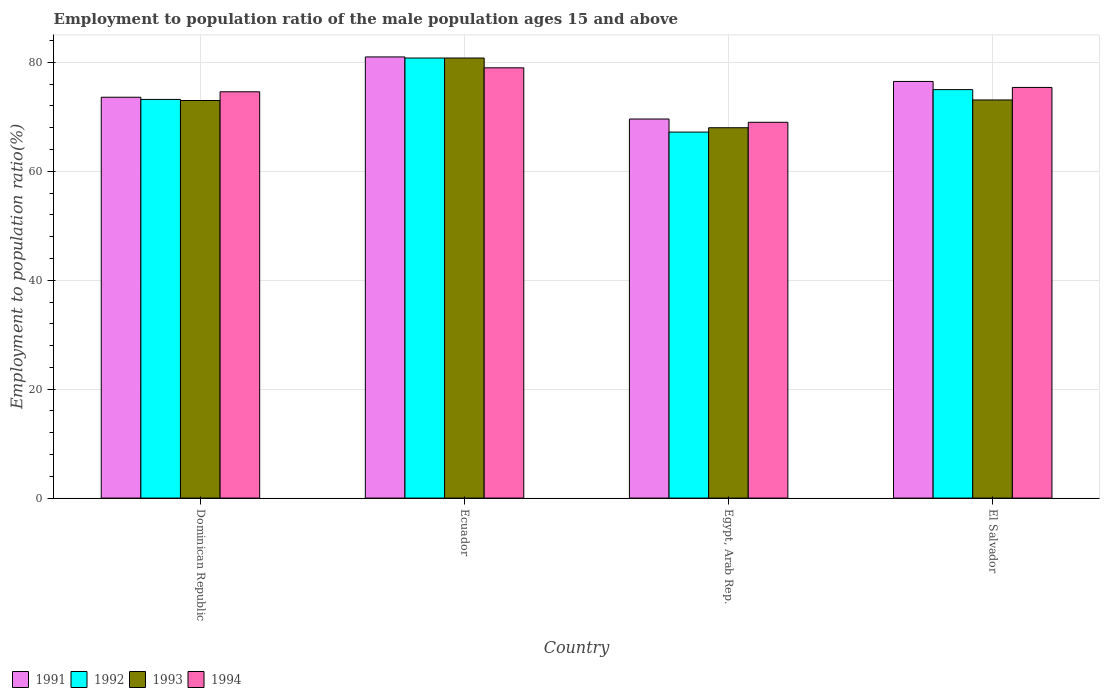What is the label of the 2nd group of bars from the left?
Give a very brief answer. Ecuador. What is the employment to population ratio in 1993 in El Salvador?
Provide a succinct answer. 73.1. Across all countries, what is the maximum employment to population ratio in 1994?
Your answer should be compact. 79. Across all countries, what is the minimum employment to population ratio in 1991?
Ensure brevity in your answer.  69.6. In which country was the employment to population ratio in 1994 maximum?
Ensure brevity in your answer.  Ecuador. In which country was the employment to population ratio in 1993 minimum?
Your answer should be compact. Egypt, Arab Rep. What is the total employment to population ratio in 1994 in the graph?
Provide a succinct answer. 298. What is the difference between the employment to population ratio in 1993 in El Salvador and the employment to population ratio in 1991 in Ecuador?
Provide a short and direct response. -7.9. What is the average employment to population ratio in 1993 per country?
Your response must be concise. 73.73. What is the difference between the employment to population ratio of/in 1994 and employment to population ratio of/in 1991 in Egypt, Arab Rep.?
Make the answer very short. -0.6. In how many countries, is the employment to population ratio in 1994 greater than 12 %?
Ensure brevity in your answer.  4. What is the ratio of the employment to population ratio in 1993 in Dominican Republic to that in Ecuador?
Offer a terse response. 0.9. Is the employment to population ratio in 1994 in Ecuador less than that in Egypt, Arab Rep.?
Ensure brevity in your answer.  No. What is the difference between the highest and the second highest employment to population ratio in 1991?
Provide a succinct answer. -7.4. What is the difference between the highest and the lowest employment to population ratio in 1994?
Provide a short and direct response. 10. Is it the case that in every country, the sum of the employment to population ratio in 1994 and employment to population ratio in 1991 is greater than the sum of employment to population ratio in 1992 and employment to population ratio in 1993?
Ensure brevity in your answer.  No. What does the 2nd bar from the right in Dominican Republic represents?
Your answer should be compact. 1993. Are all the bars in the graph horizontal?
Provide a short and direct response. No. What is the difference between two consecutive major ticks on the Y-axis?
Offer a very short reply. 20. Does the graph contain any zero values?
Your answer should be very brief. No. Does the graph contain grids?
Your answer should be compact. Yes. How are the legend labels stacked?
Your answer should be compact. Horizontal. What is the title of the graph?
Offer a terse response. Employment to population ratio of the male population ages 15 and above. What is the label or title of the X-axis?
Make the answer very short. Country. What is the label or title of the Y-axis?
Provide a short and direct response. Employment to population ratio(%). What is the Employment to population ratio(%) in 1991 in Dominican Republic?
Keep it short and to the point. 73.6. What is the Employment to population ratio(%) in 1992 in Dominican Republic?
Ensure brevity in your answer.  73.2. What is the Employment to population ratio(%) in 1994 in Dominican Republic?
Your answer should be very brief. 74.6. What is the Employment to population ratio(%) in 1992 in Ecuador?
Your answer should be very brief. 80.8. What is the Employment to population ratio(%) of 1993 in Ecuador?
Your answer should be compact. 80.8. What is the Employment to population ratio(%) of 1994 in Ecuador?
Your answer should be compact. 79. What is the Employment to population ratio(%) of 1991 in Egypt, Arab Rep.?
Offer a terse response. 69.6. What is the Employment to population ratio(%) in 1992 in Egypt, Arab Rep.?
Ensure brevity in your answer.  67.2. What is the Employment to population ratio(%) in 1993 in Egypt, Arab Rep.?
Give a very brief answer. 68. What is the Employment to population ratio(%) in 1991 in El Salvador?
Your answer should be compact. 76.5. What is the Employment to population ratio(%) in 1992 in El Salvador?
Provide a succinct answer. 75. What is the Employment to population ratio(%) in 1993 in El Salvador?
Your answer should be very brief. 73.1. What is the Employment to population ratio(%) in 1994 in El Salvador?
Your answer should be compact. 75.4. Across all countries, what is the maximum Employment to population ratio(%) of 1992?
Offer a very short reply. 80.8. Across all countries, what is the maximum Employment to population ratio(%) of 1993?
Offer a very short reply. 80.8. Across all countries, what is the maximum Employment to population ratio(%) of 1994?
Your answer should be very brief. 79. Across all countries, what is the minimum Employment to population ratio(%) of 1991?
Offer a terse response. 69.6. Across all countries, what is the minimum Employment to population ratio(%) in 1992?
Your answer should be compact. 67.2. What is the total Employment to population ratio(%) of 1991 in the graph?
Provide a succinct answer. 300.7. What is the total Employment to population ratio(%) of 1992 in the graph?
Keep it short and to the point. 296.2. What is the total Employment to population ratio(%) of 1993 in the graph?
Make the answer very short. 294.9. What is the total Employment to population ratio(%) in 1994 in the graph?
Your answer should be very brief. 298. What is the difference between the Employment to population ratio(%) of 1991 in Dominican Republic and that in Ecuador?
Provide a short and direct response. -7.4. What is the difference between the Employment to population ratio(%) of 1993 in Dominican Republic and that in Ecuador?
Ensure brevity in your answer.  -7.8. What is the difference between the Employment to population ratio(%) of 1994 in Dominican Republic and that in Ecuador?
Your response must be concise. -4.4. What is the difference between the Employment to population ratio(%) in 1993 in Dominican Republic and that in Egypt, Arab Rep.?
Your response must be concise. 5. What is the difference between the Employment to population ratio(%) of 1992 in Dominican Republic and that in El Salvador?
Keep it short and to the point. -1.8. What is the difference between the Employment to population ratio(%) in 1993 in Dominican Republic and that in El Salvador?
Your answer should be compact. -0.1. What is the difference between the Employment to population ratio(%) of 1991 in Ecuador and that in Egypt, Arab Rep.?
Offer a terse response. 11.4. What is the difference between the Employment to population ratio(%) of 1994 in Ecuador and that in Egypt, Arab Rep.?
Keep it short and to the point. 10. What is the difference between the Employment to population ratio(%) of 1992 in Ecuador and that in El Salvador?
Offer a terse response. 5.8. What is the difference between the Employment to population ratio(%) of 1993 in Ecuador and that in El Salvador?
Your answer should be compact. 7.7. What is the difference between the Employment to population ratio(%) in 1991 in Egypt, Arab Rep. and that in El Salvador?
Keep it short and to the point. -6.9. What is the difference between the Employment to population ratio(%) in 1991 in Dominican Republic and the Employment to population ratio(%) in 1993 in Ecuador?
Give a very brief answer. -7.2. What is the difference between the Employment to population ratio(%) of 1991 in Dominican Republic and the Employment to population ratio(%) of 1994 in Ecuador?
Offer a very short reply. -5.4. What is the difference between the Employment to population ratio(%) of 1991 in Dominican Republic and the Employment to population ratio(%) of 1993 in Egypt, Arab Rep.?
Give a very brief answer. 5.6. What is the difference between the Employment to population ratio(%) of 1991 in Dominican Republic and the Employment to population ratio(%) of 1994 in Egypt, Arab Rep.?
Provide a succinct answer. 4.6. What is the difference between the Employment to population ratio(%) in 1992 in Dominican Republic and the Employment to population ratio(%) in 1994 in Egypt, Arab Rep.?
Provide a short and direct response. 4.2. What is the difference between the Employment to population ratio(%) in 1991 in Dominican Republic and the Employment to population ratio(%) in 1992 in El Salvador?
Give a very brief answer. -1.4. What is the difference between the Employment to population ratio(%) of 1991 in Dominican Republic and the Employment to population ratio(%) of 1993 in El Salvador?
Your answer should be compact. 0.5. What is the difference between the Employment to population ratio(%) in 1992 in Dominican Republic and the Employment to population ratio(%) in 1994 in El Salvador?
Give a very brief answer. -2.2. What is the difference between the Employment to population ratio(%) in 1991 in Ecuador and the Employment to population ratio(%) in 1994 in Egypt, Arab Rep.?
Offer a very short reply. 12. What is the difference between the Employment to population ratio(%) of 1992 in Ecuador and the Employment to population ratio(%) of 1993 in Egypt, Arab Rep.?
Provide a succinct answer. 12.8. What is the difference between the Employment to population ratio(%) in 1991 in Ecuador and the Employment to population ratio(%) in 1994 in El Salvador?
Offer a terse response. 5.6. What is the difference between the Employment to population ratio(%) in 1992 in Ecuador and the Employment to population ratio(%) in 1993 in El Salvador?
Offer a terse response. 7.7. What is the difference between the Employment to population ratio(%) in 1992 in Egypt, Arab Rep. and the Employment to population ratio(%) in 1993 in El Salvador?
Ensure brevity in your answer.  -5.9. What is the average Employment to population ratio(%) of 1991 per country?
Keep it short and to the point. 75.17. What is the average Employment to population ratio(%) of 1992 per country?
Provide a short and direct response. 74.05. What is the average Employment to population ratio(%) in 1993 per country?
Your response must be concise. 73.72. What is the average Employment to population ratio(%) in 1994 per country?
Your answer should be compact. 74.5. What is the difference between the Employment to population ratio(%) in 1992 and Employment to population ratio(%) in 1994 in Dominican Republic?
Provide a succinct answer. -1.4. What is the difference between the Employment to population ratio(%) of 1993 and Employment to population ratio(%) of 1994 in Dominican Republic?
Your answer should be compact. -1.6. What is the difference between the Employment to population ratio(%) of 1991 and Employment to population ratio(%) of 1993 in Ecuador?
Offer a very short reply. 0.2. What is the difference between the Employment to population ratio(%) in 1991 and Employment to population ratio(%) in 1994 in Ecuador?
Your response must be concise. 2. What is the difference between the Employment to population ratio(%) of 1993 and Employment to population ratio(%) of 1994 in Ecuador?
Your answer should be compact. 1.8. What is the difference between the Employment to population ratio(%) in 1991 and Employment to population ratio(%) in 1994 in Egypt, Arab Rep.?
Give a very brief answer. 0.6. What is the difference between the Employment to population ratio(%) in 1991 and Employment to population ratio(%) in 1992 in El Salvador?
Offer a terse response. 1.5. What is the difference between the Employment to population ratio(%) in 1991 and Employment to population ratio(%) in 1993 in El Salvador?
Keep it short and to the point. 3.4. What is the difference between the Employment to population ratio(%) in 1991 and Employment to population ratio(%) in 1994 in El Salvador?
Your answer should be very brief. 1.1. What is the ratio of the Employment to population ratio(%) in 1991 in Dominican Republic to that in Ecuador?
Your answer should be very brief. 0.91. What is the ratio of the Employment to population ratio(%) in 1992 in Dominican Republic to that in Ecuador?
Offer a terse response. 0.91. What is the ratio of the Employment to population ratio(%) in 1993 in Dominican Republic to that in Ecuador?
Your answer should be very brief. 0.9. What is the ratio of the Employment to population ratio(%) of 1994 in Dominican Republic to that in Ecuador?
Keep it short and to the point. 0.94. What is the ratio of the Employment to population ratio(%) of 1991 in Dominican Republic to that in Egypt, Arab Rep.?
Your response must be concise. 1.06. What is the ratio of the Employment to population ratio(%) of 1992 in Dominican Republic to that in Egypt, Arab Rep.?
Make the answer very short. 1.09. What is the ratio of the Employment to population ratio(%) in 1993 in Dominican Republic to that in Egypt, Arab Rep.?
Keep it short and to the point. 1.07. What is the ratio of the Employment to population ratio(%) of 1994 in Dominican Republic to that in Egypt, Arab Rep.?
Make the answer very short. 1.08. What is the ratio of the Employment to population ratio(%) of 1991 in Dominican Republic to that in El Salvador?
Provide a succinct answer. 0.96. What is the ratio of the Employment to population ratio(%) in 1991 in Ecuador to that in Egypt, Arab Rep.?
Your answer should be very brief. 1.16. What is the ratio of the Employment to population ratio(%) of 1992 in Ecuador to that in Egypt, Arab Rep.?
Your response must be concise. 1.2. What is the ratio of the Employment to population ratio(%) of 1993 in Ecuador to that in Egypt, Arab Rep.?
Provide a short and direct response. 1.19. What is the ratio of the Employment to population ratio(%) in 1994 in Ecuador to that in Egypt, Arab Rep.?
Provide a short and direct response. 1.14. What is the ratio of the Employment to population ratio(%) of 1991 in Ecuador to that in El Salvador?
Provide a succinct answer. 1.06. What is the ratio of the Employment to population ratio(%) of 1992 in Ecuador to that in El Salvador?
Your response must be concise. 1.08. What is the ratio of the Employment to population ratio(%) of 1993 in Ecuador to that in El Salvador?
Your answer should be very brief. 1.11. What is the ratio of the Employment to population ratio(%) in 1994 in Ecuador to that in El Salvador?
Ensure brevity in your answer.  1.05. What is the ratio of the Employment to population ratio(%) of 1991 in Egypt, Arab Rep. to that in El Salvador?
Give a very brief answer. 0.91. What is the ratio of the Employment to population ratio(%) of 1992 in Egypt, Arab Rep. to that in El Salvador?
Keep it short and to the point. 0.9. What is the ratio of the Employment to population ratio(%) of 1993 in Egypt, Arab Rep. to that in El Salvador?
Your response must be concise. 0.93. What is the ratio of the Employment to population ratio(%) in 1994 in Egypt, Arab Rep. to that in El Salvador?
Offer a terse response. 0.92. What is the difference between the highest and the second highest Employment to population ratio(%) in 1992?
Make the answer very short. 5.8. What is the difference between the highest and the second highest Employment to population ratio(%) of 1993?
Offer a very short reply. 7.7. What is the difference between the highest and the lowest Employment to population ratio(%) in 1992?
Ensure brevity in your answer.  13.6. 